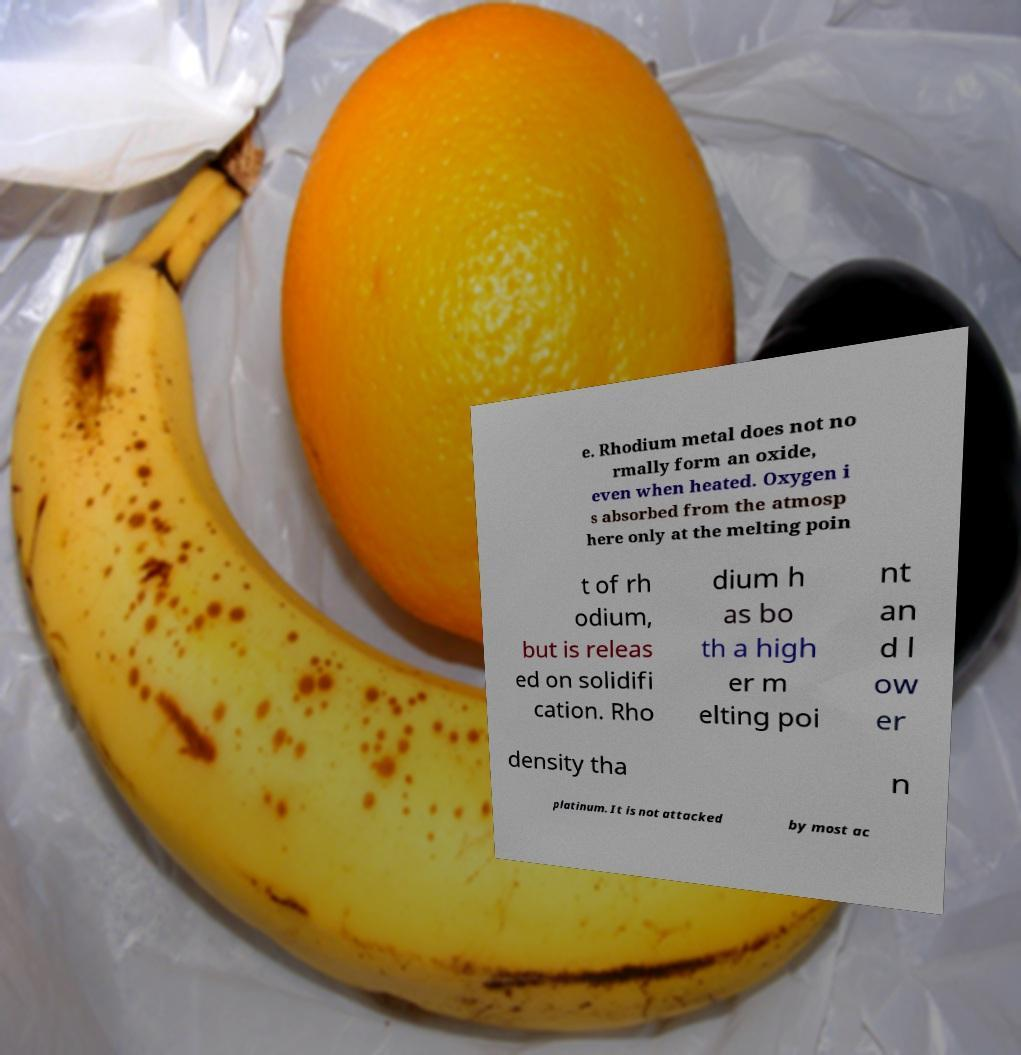There's text embedded in this image that I need extracted. Can you transcribe it verbatim? e. Rhodium metal does not no rmally form an oxide, even when heated. Oxygen i s absorbed from the atmosp here only at the melting poin t of rh odium, but is releas ed on solidifi cation. Rho dium h as bo th a high er m elting poi nt an d l ow er density tha n platinum. It is not attacked by most ac 